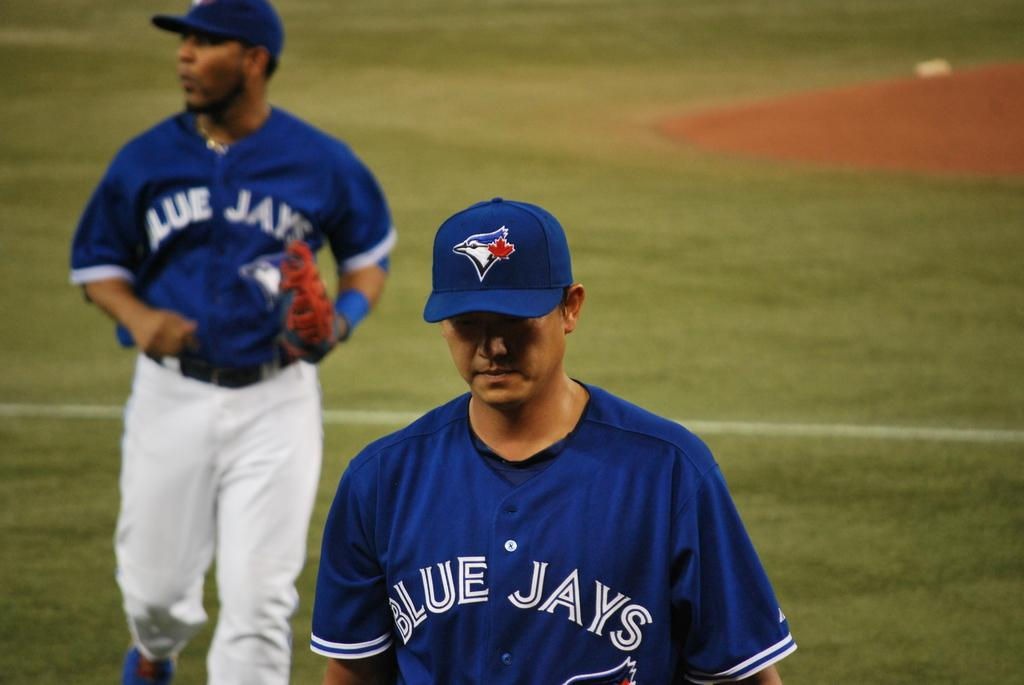<image>
Create a compact narrative representing the image presented. Blue Jays Jersey with a jay bird logo on a cap. 